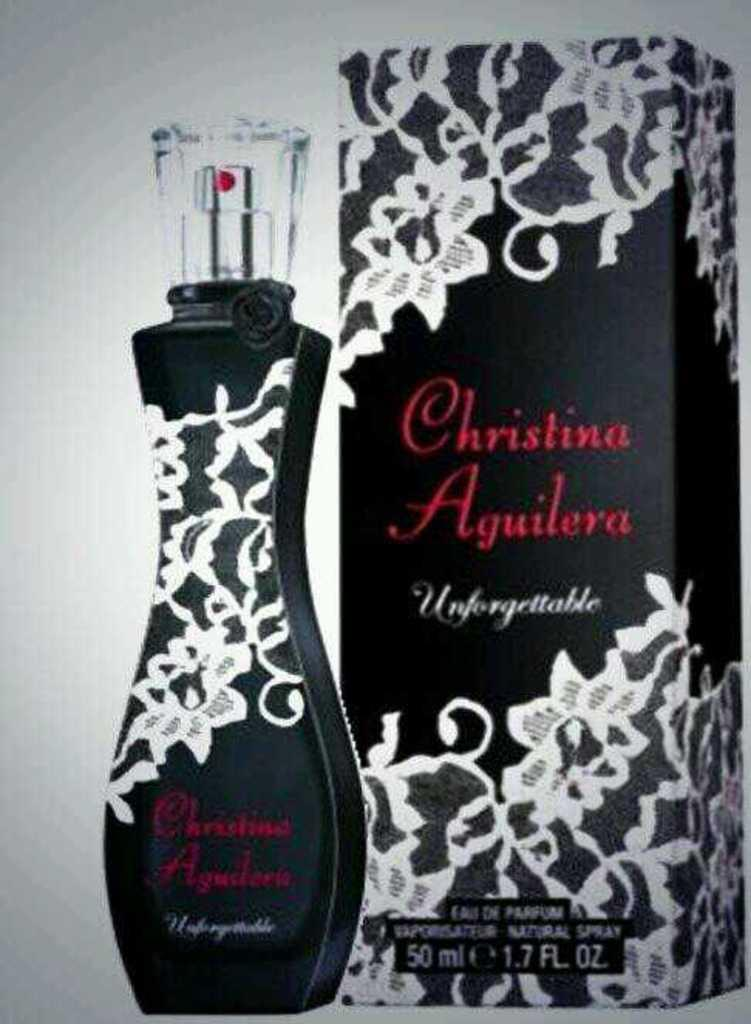<image>
Write a terse but informative summary of the picture. A black and white lace box for Unforgettable perfume. 